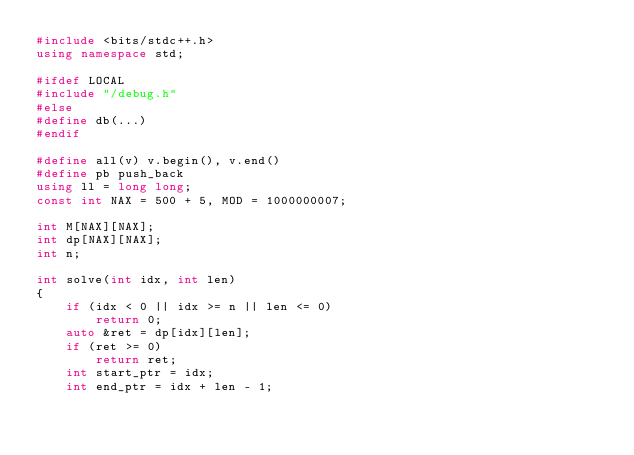<code> <loc_0><loc_0><loc_500><loc_500><_C++_>#include <bits/stdc++.h>
using namespace std;

#ifdef LOCAL
#include "/debug.h"
#else
#define db(...)
#endif

#define all(v) v.begin(), v.end()
#define pb push_back
using ll = long long;
const int NAX = 500 + 5, MOD = 1000000007;

int M[NAX][NAX];
int dp[NAX][NAX];
int n;

int solve(int idx, int len)
{
    if (idx < 0 || idx >= n || len <= 0)
        return 0;
    auto &ret = dp[idx][len];
    if (ret >= 0)
        return ret;
    int start_ptr = idx;
    int end_ptr = idx + len - 1;</code> 